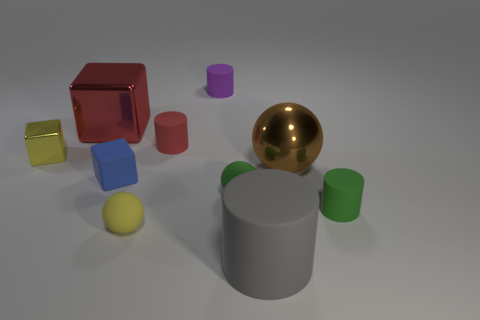The other matte thing that is the same shape as the yellow rubber object is what size?
Your response must be concise. Small. How many cylinders have the same material as the tiny red object?
Offer a very short reply. 3. How many things have the same color as the matte cube?
Your response must be concise. 0. What number of objects are objects left of the blue cube or tiny purple things behind the large red metal cube?
Provide a succinct answer. 3. Are there fewer rubber cylinders in front of the tiny red object than purple metal things?
Ensure brevity in your answer.  No. Are there any red balls that have the same size as the brown metal sphere?
Provide a short and direct response. No. The big rubber cylinder has what color?
Provide a succinct answer. Gray. Do the gray rubber cylinder and the yellow rubber ball have the same size?
Give a very brief answer. No. How many objects are yellow cylinders or big shiny cubes?
Offer a terse response. 1. Are there an equal number of large objects that are behind the large block and large green rubber spheres?
Provide a succinct answer. Yes. 